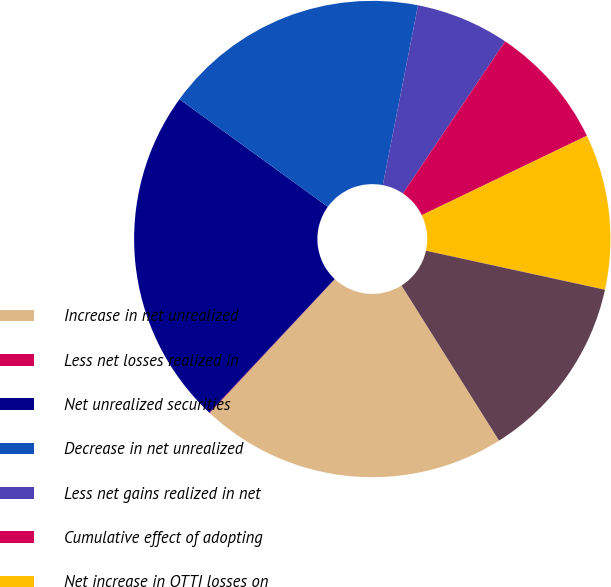<chart> <loc_0><loc_0><loc_500><loc_500><pie_chart><fcel>Increase in net unrealized<fcel>Less net losses realized in<fcel>Net unrealized securities<fcel>Decrease in net unrealized<fcel>Less net gains realized in net<fcel>Cumulative effect of adopting<fcel>Net increase in OTTI losses on<fcel>Net OTTI losses on debt<nl><fcel>20.89%<fcel>0.04%<fcel>22.99%<fcel>18.09%<fcel>6.34%<fcel>8.45%<fcel>10.55%<fcel>12.65%<nl></chart> 